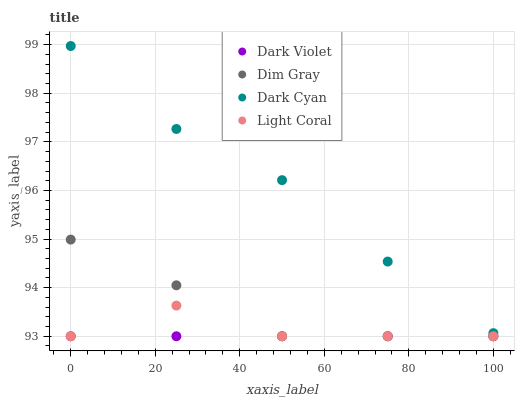Does Dark Violet have the minimum area under the curve?
Answer yes or no. Yes. Does Dark Cyan have the maximum area under the curve?
Answer yes or no. Yes. Does Light Coral have the minimum area under the curve?
Answer yes or no. No. Does Light Coral have the maximum area under the curve?
Answer yes or no. No. Is Dark Violet the smoothest?
Answer yes or no. Yes. Is Light Coral the roughest?
Answer yes or no. Yes. Is Dim Gray the smoothest?
Answer yes or no. No. Is Dim Gray the roughest?
Answer yes or no. No. Does Light Coral have the lowest value?
Answer yes or no. Yes. Does Dark Cyan have the highest value?
Answer yes or no. Yes. Does Light Coral have the highest value?
Answer yes or no. No. Is Dark Violet less than Dark Cyan?
Answer yes or no. Yes. Is Dark Cyan greater than Light Coral?
Answer yes or no. Yes. Does Light Coral intersect Dark Violet?
Answer yes or no. Yes. Is Light Coral less than Dark Violet?
Answer yes or no. No. Is Light Coral greater than Dark Violet?
Answer yes or no. No. Does Dark Violet intersect Dark Cyan?
Answer yes or no. No. 